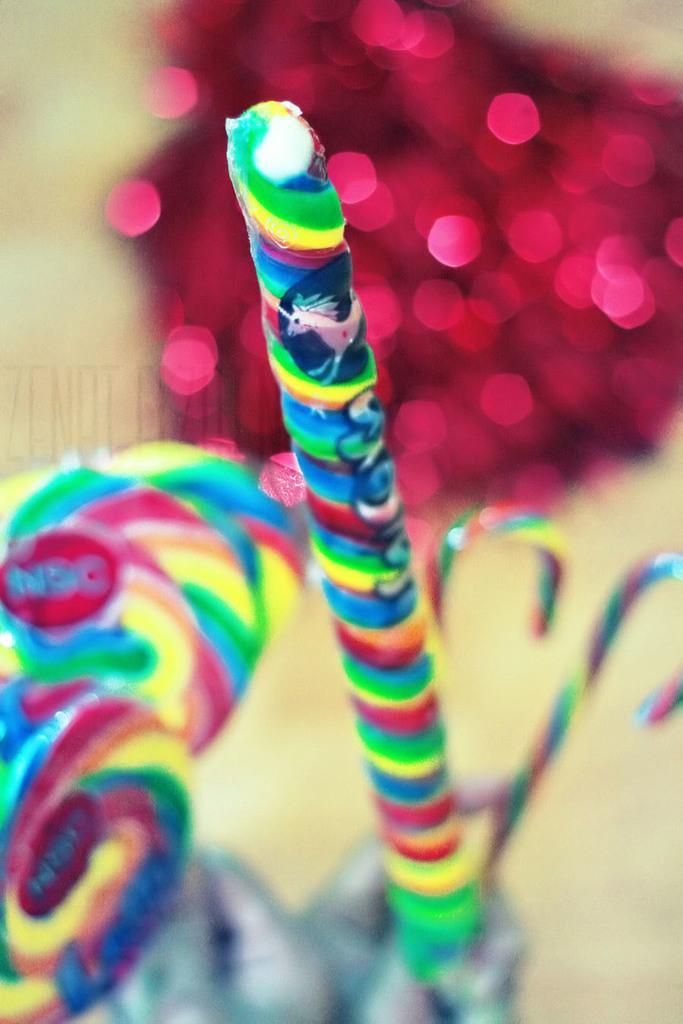In one or two sentences, can you explain what this image depicts? In this picture we can see few candies and blurry background. 